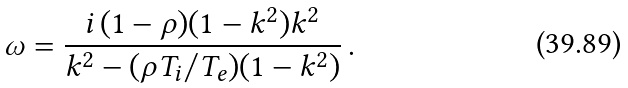<formula> <loc_0><loc_0><loc_500><loc_500>\omega = \frac { i \, ( 1 - \rho ) ( 1 - k ^ { 2 } ) k ^ { 2 } } { k ^ { 2 } - ( \rho T _ { i } / T _ { e } ) ( 1 - k ^ { 2 } ) } \, .</formula> 